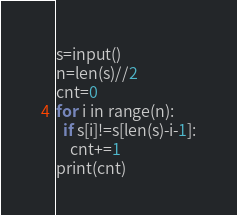Convert code to text. <code><loc_0><loc_0><loc_500><loc_500><_Python_>s=input()
n=len(s)//2
cnt=0
for i in range(n):
  if s[i]!=s[len(s)-i-1]:
    cnt+=1
print(cnt)
</code> 